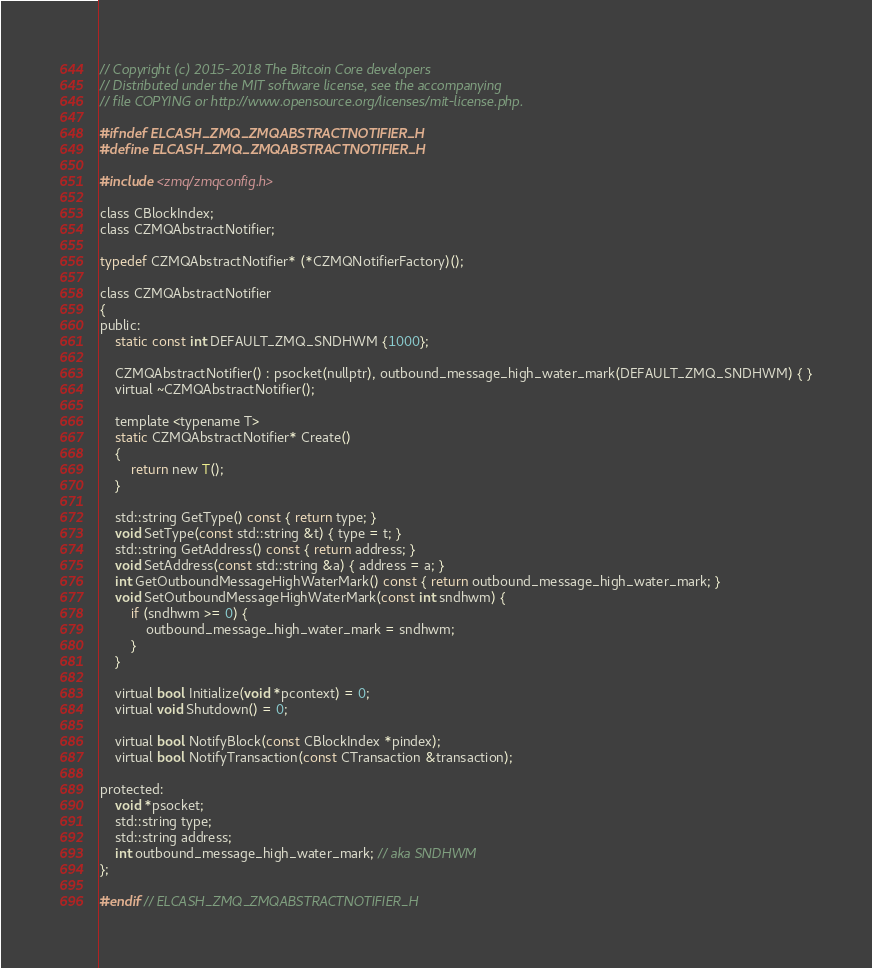<code> <loc_0><loc_0><loc_500><loc_500><_C_>// Copyright (c) 2015-2018 The Bitcoin Core developers
// Distributed under the MIT software license, see the accompanying
// file COPYING or http://www.opensource.org/licenses/mit-license.php.

#ifndef ELCASH_ZMQ_ZMQABSTRACTNOTIFIER_H
#define ELCASH_ZMQ_ZMQABSTRACTNOTIFIER_H

#include <zmq/zmqconfig.h>

class CBlockIndex;
class CZMQAbstractNotifier;

typedef CZMQAbstractNotifier* (*CZMQNotifierFactory)();

class CZMQAbstractNotifier
{
public:
    static const int DEFAULT_ZMQ_SNDHWM {1000};

    CZMQAbstractNotifier() : psocket(nullptr), outbound_message_high_water_mark(DEFAULT_ZMQ_SNDHWM) { }
    virtual ~CZMQAbstractNotifier();

    template <typename T>
    static CZMQAbstractNotifier* Create()
    {
        return new T();
    }

    std::string GetType() const { return type; }
    void SetType(const std::string &t) { type = t; }
    std::string GetAddress() const { return address; }
    void SetAddress(const std::string &a) { address = a; }
    int GetOutboundMessageHighWaterMark() const { return outbound_message_high_water_mark; }
    void SetOutboundMessageHighWaterMark(const int sndhwm) {
        if (sndhwm >= 0) {
            outbound_message_high_water_mark = sndhwm;
        }
    }

    virtual bool Initialize(void *pcontext) = 0;
    virtual void Shutdown() = 0;

    virtual bool NotifyBlock(const CBlockIndex *pindex);
    virtual bool NotifyTransaction(const CTransaction &transaction);

protected:
    void *psocket;
    std::string type;
    std::string address;
    int outbound_message_high_water_mark; // aka SNDHWM
};

#endif // ELCASH_ZMQ_ZMQABSTRACTNOTIFIER_H
</code> 